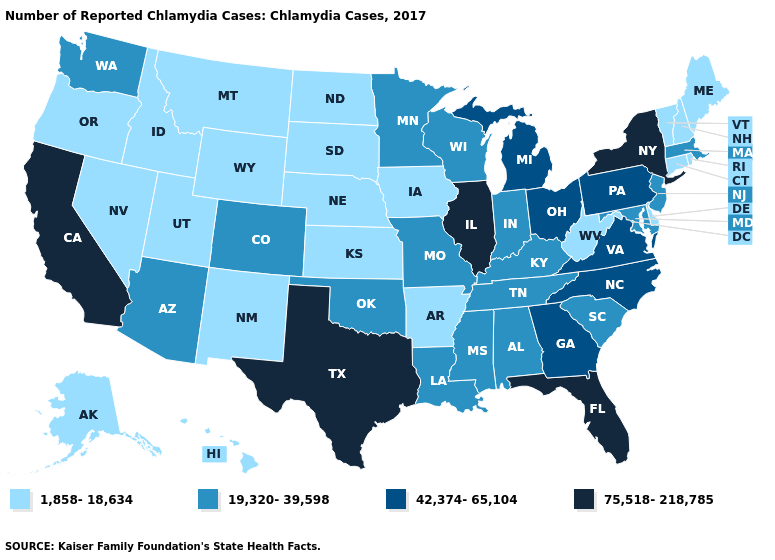Is the legend a continuous bar?
Short answer required. No. What is the value of West Virginia?
Write a very short answer. 1,858-18,634. What is the value of Indiana?
Keep it brief. 19,320-39,598. Among the states that border New Hampshire , which have the lowest value?
Be succinct. Maine, Vermont. Is the legend a continuous bar?
Be succinct. No. Does Kansas have the highest value in the MidWest?
Write a very short answer. No. Does the map have missing data?
Keep it brief. No. Among the states that border Utah , which have the highest value?
Write a very short answer. Arizona, Colorado. How many symbols are there in the legend?
Concise answer only. 4. Name the states that have a value in the range 1,858-18,634?
Give a very brief answer. Alaska, Arkansas, Connecticut, Delaware, Hawaii, Idaho, Iowa, Kansas, Maine, Montana, Nebraska, Nevada, New Hampshire, New Mexico, North Dakota, Oregon, Rhode Island, South Dakota, Utah, Vermont, West Virginia, Wyoming. What is the value of West Virginia?
Write a very short answer. 1,858-18,634. What is the lowest value in states that border Maryland?
Short answer required. 1,858-18,634. Does Illinois have the highest value in the MidWest?
Answer briefly. Yes. 